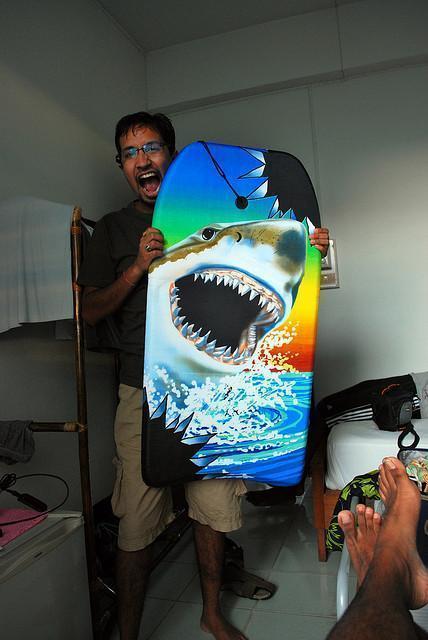What is the item being displayed by the man?
Select the correct answer and articulate reasoning with the following format: 'Answer: answer
Rationale: rationale.'
Options: Floaty, surf board, drawing, wall paper. Answer: floaty.
Rationale: The man is holding a body board. What water sport is the object the man is holding used in?
Indicate the correct response by choosing from the four available options to answer the question.
Options: Wakeboarding, windsurfing, surfing, bodyboarding. Bodyboarding. 